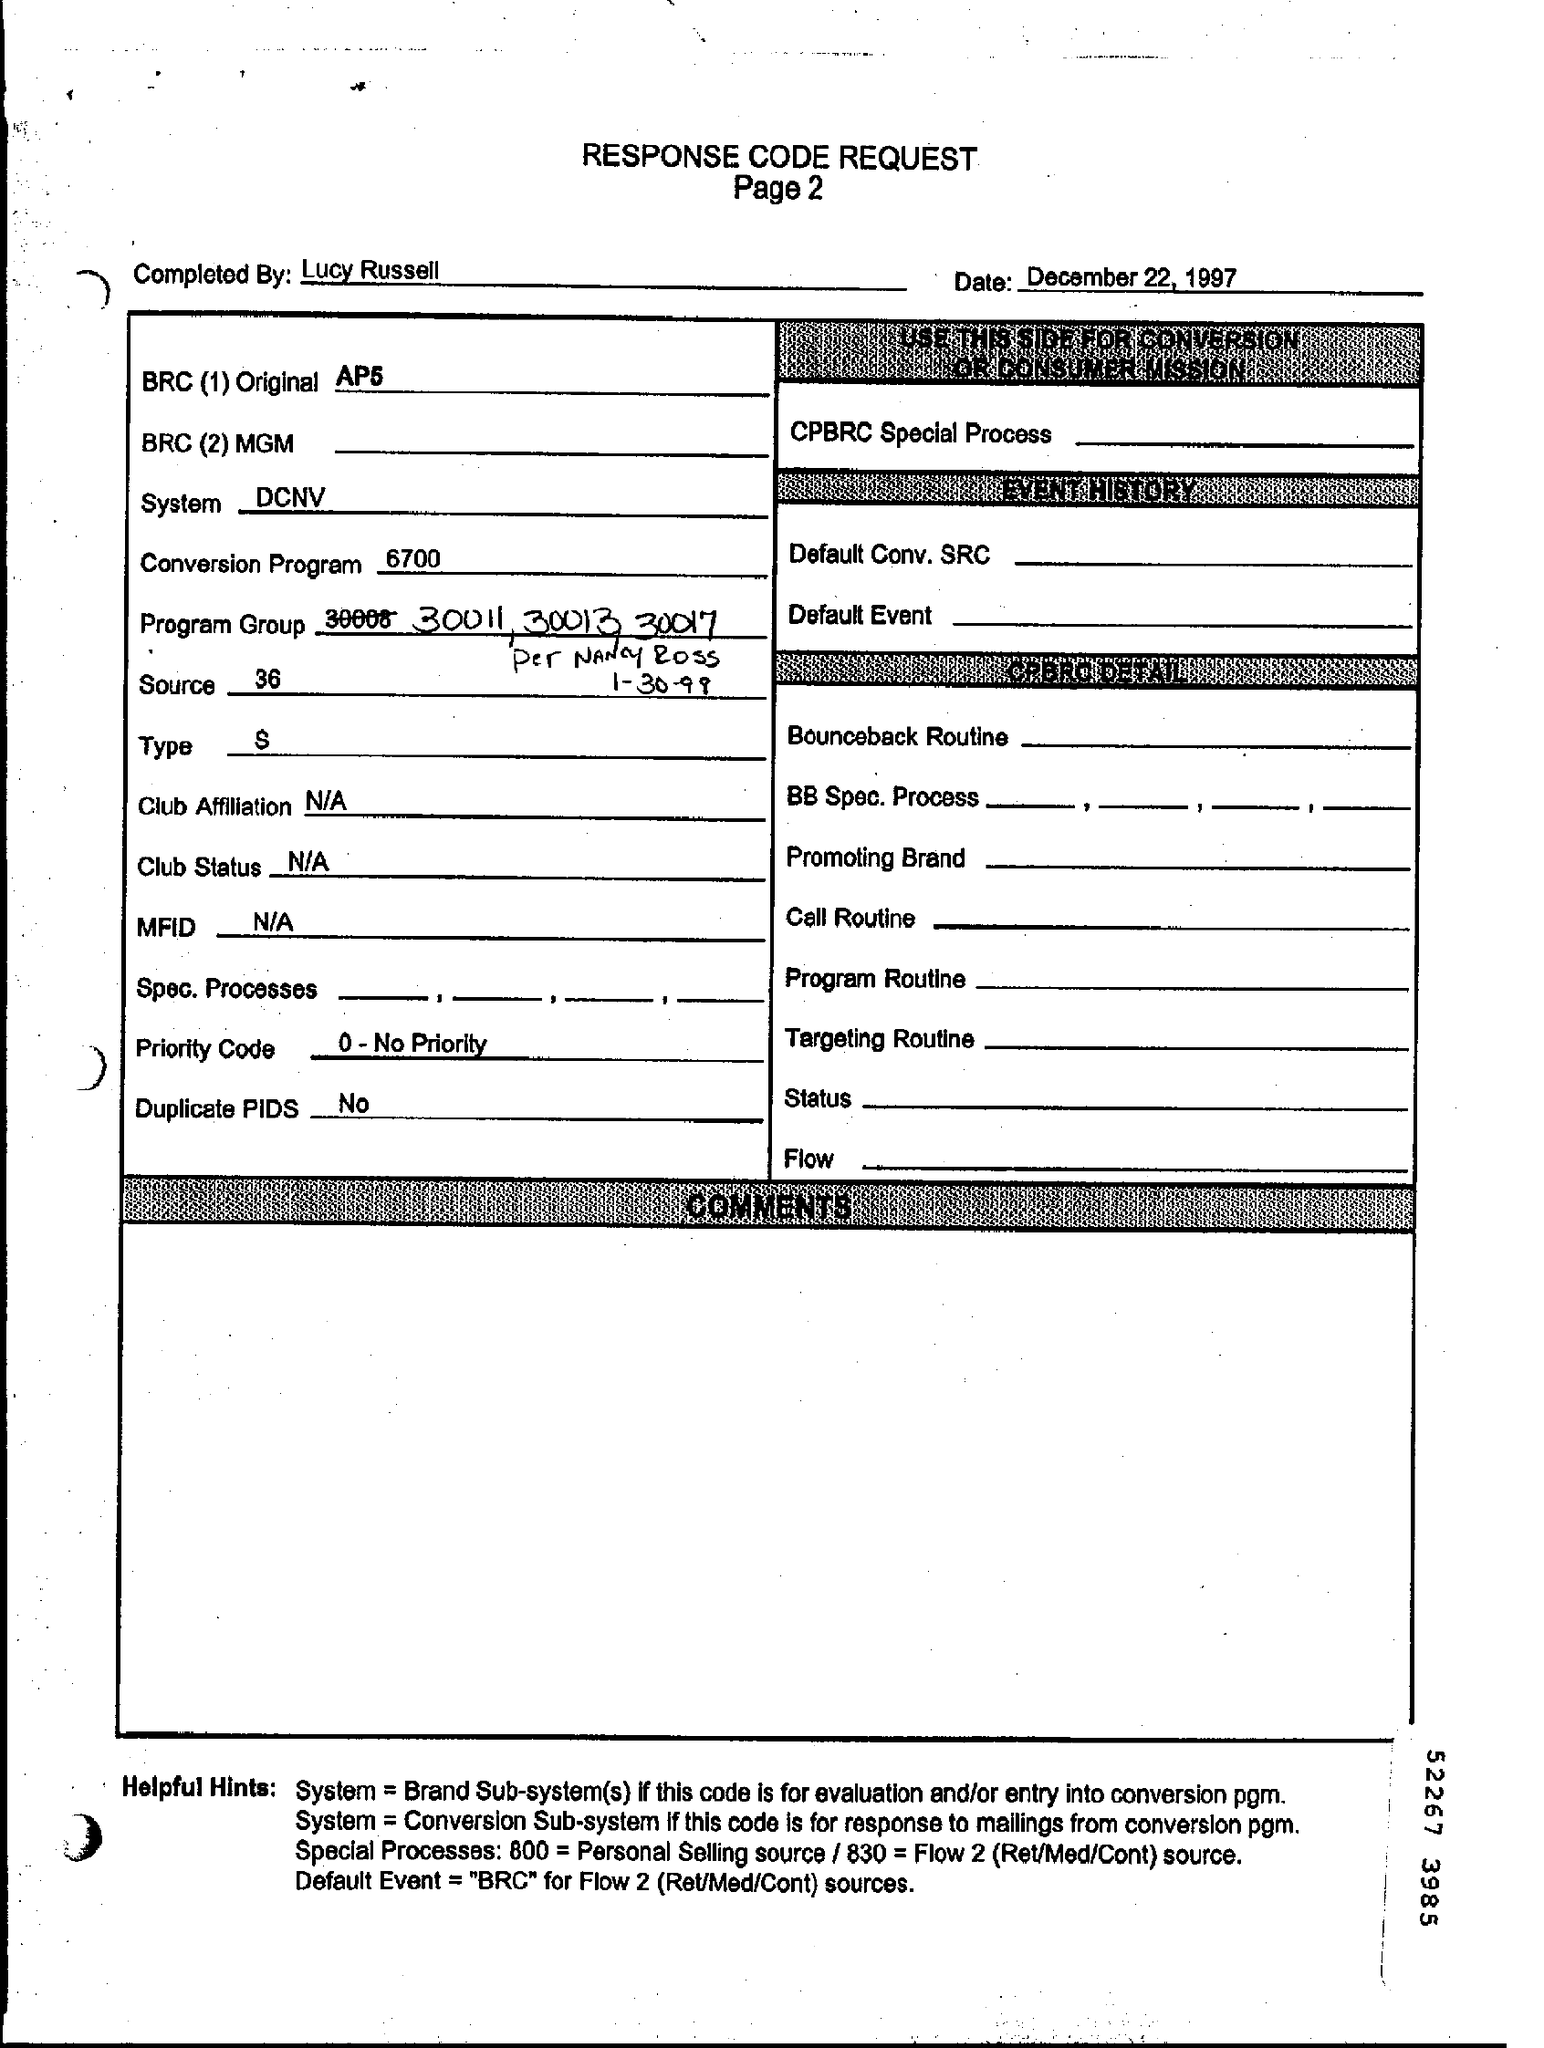Give some essential details in this illustration. The completion of the REQUEST was performed by Lucy Russell. The system used in response code request is DCNV. What is the type? Shall I proceed with the declaration? 